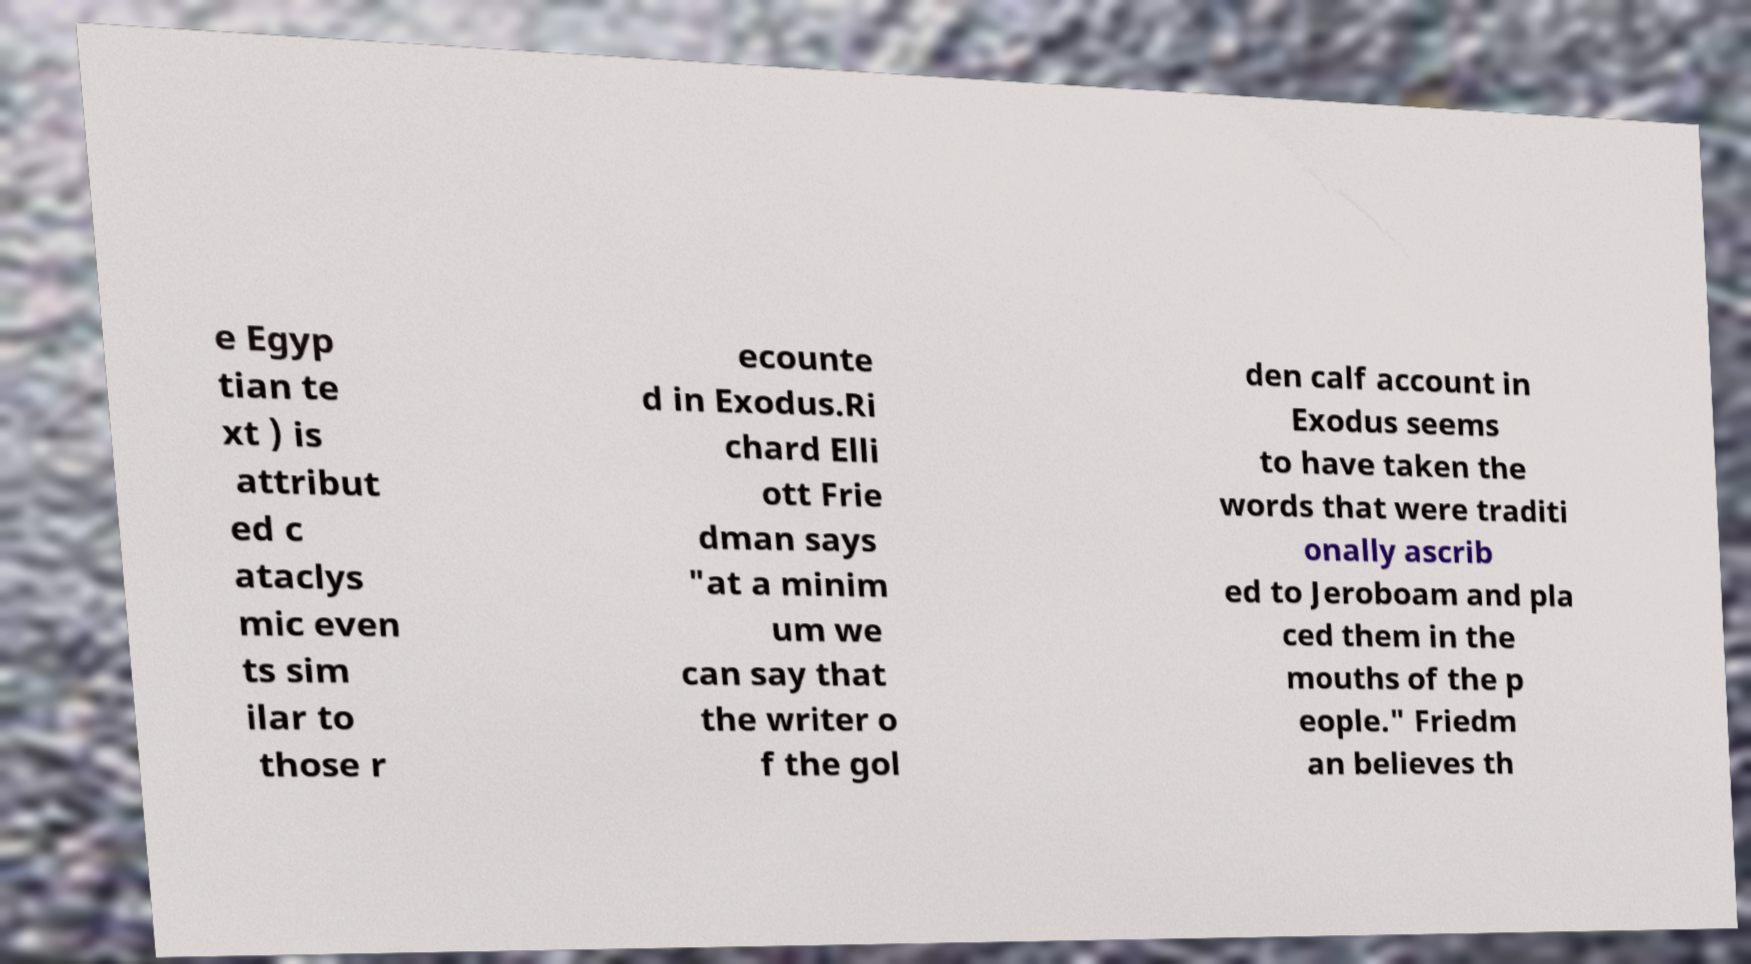Can you accurately transcribe the text from the provided image for me? e Egyp tian te xt ) is attribut ed c ataclys mic even ts sim ilar to those r ecounte d in Exodus.Ri chard Elli ott Frie dman says "at a minim um we can say that the writer o f the gol den calf account in Exodus seems to have taken the words that were traditi onally ascrib ed to Jeroboam and pla ced them in the mouths of the p eople." Friedm an believes th 